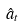<formula> <loc_0><loc_0><loc_500><loc_500>\hat { a } _ { t }</formula> 